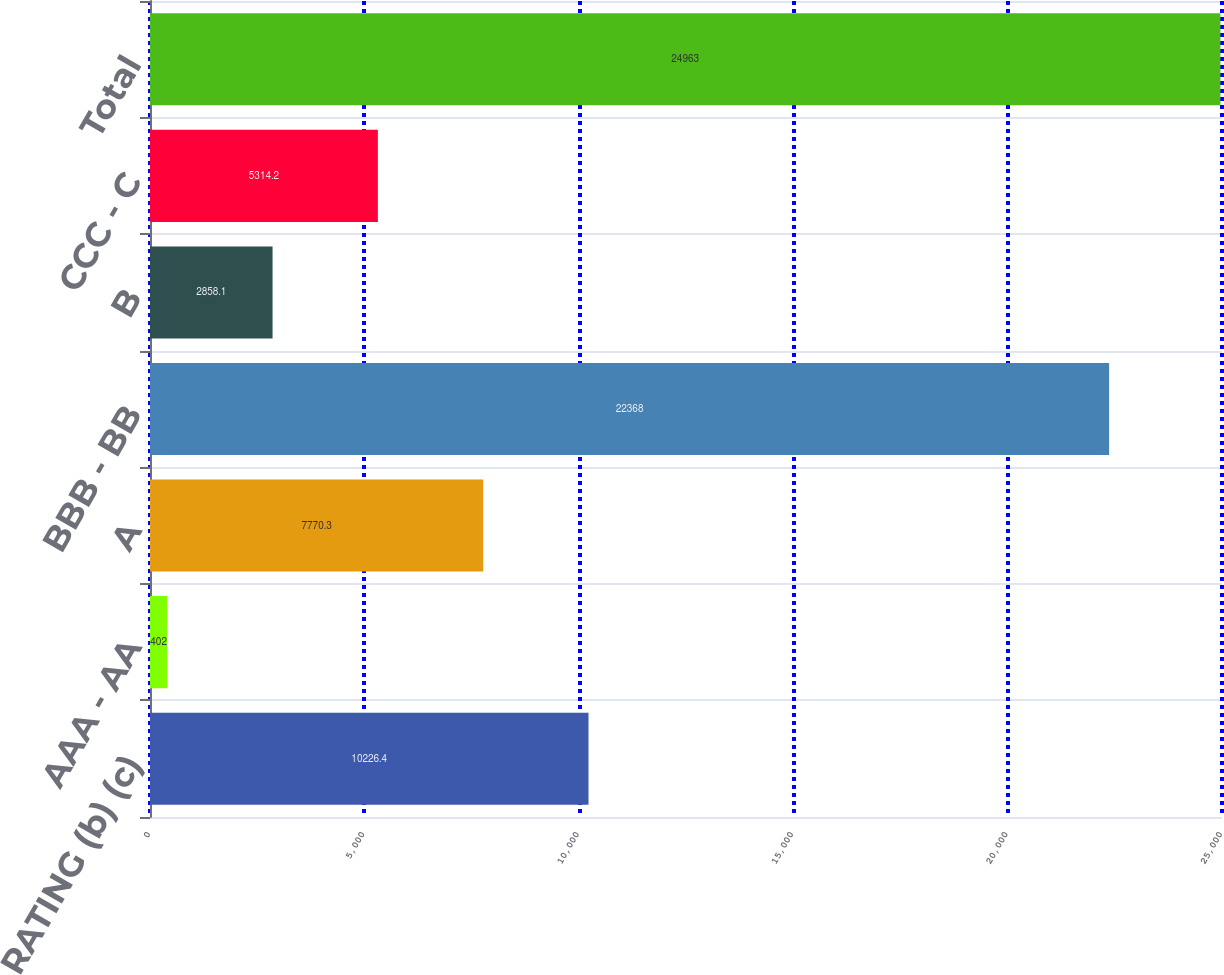Convert chart. <chart><loc_0><loc_0><loc_500><loc_500><bar_chart><fcel>RATING (b) (c)<fcel>AAA - AA<fcel>A<fcel>BBB - BB<fcel>B<fcel>CCC - C<fcel>Total<nl><fcel>10226.4<fcel>402<fcel>7770.3<fcel>22368<fcel>2858.1<fcel>5314.2<fcel>24963<nl></chart> 